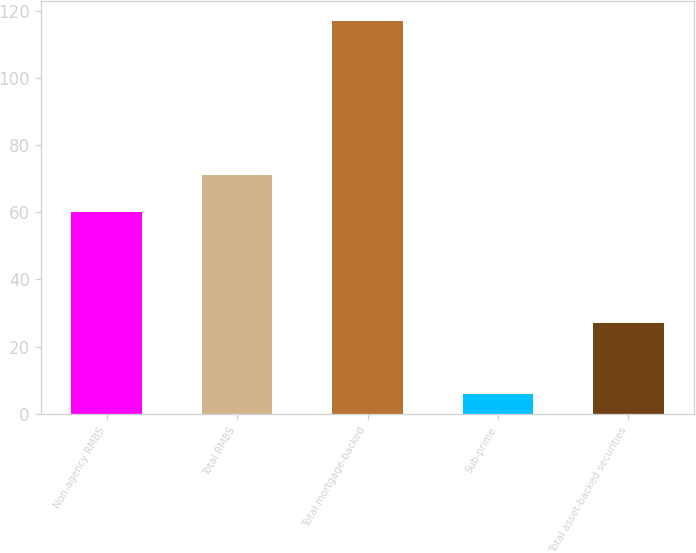Convert chart. <chart><loc_0><loc_0><loc_500><loc_500><bar_chart><fcel>Non-agency RMBS<fcel>Total RMBS<fcel>Total mortgage-backed<fcel>Sub-prime<fcel>Total asset-backed securities<nl><fcel>60<fcel>71.1<fcel>117<fcel>6<fcel>27<nl></chart> 